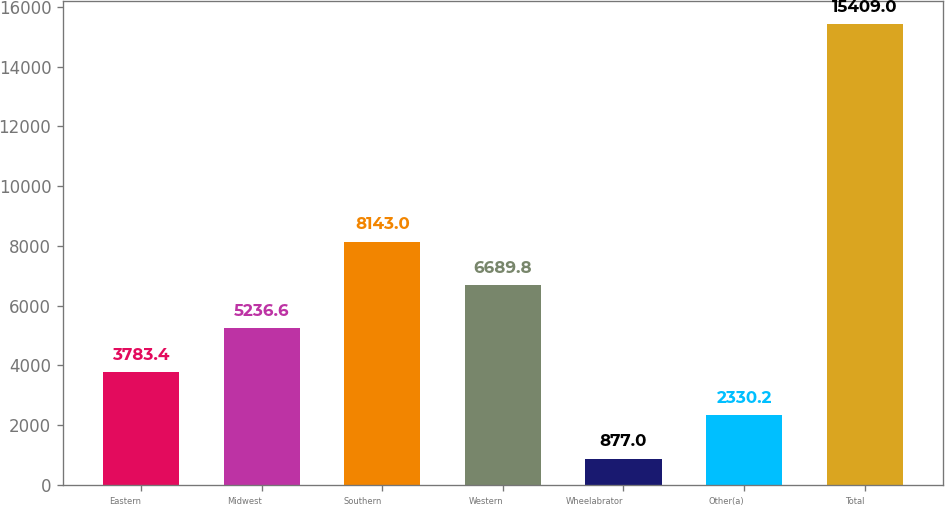<chart> <loc_0><loc_0><loc_500><loc_500><bar_chart><fcel>Eastern<fcel>Midwest<fcel>Southern<fcel>Western<fcel>Wheelabrator<fcel>Other(a)<fcel>Total<nl><fcel>3783.4<fcel>5236.6<fcel>8143<fcel>6689.8<fcel>877<fcel>2330.2<fcel>15409<nl></chart> 